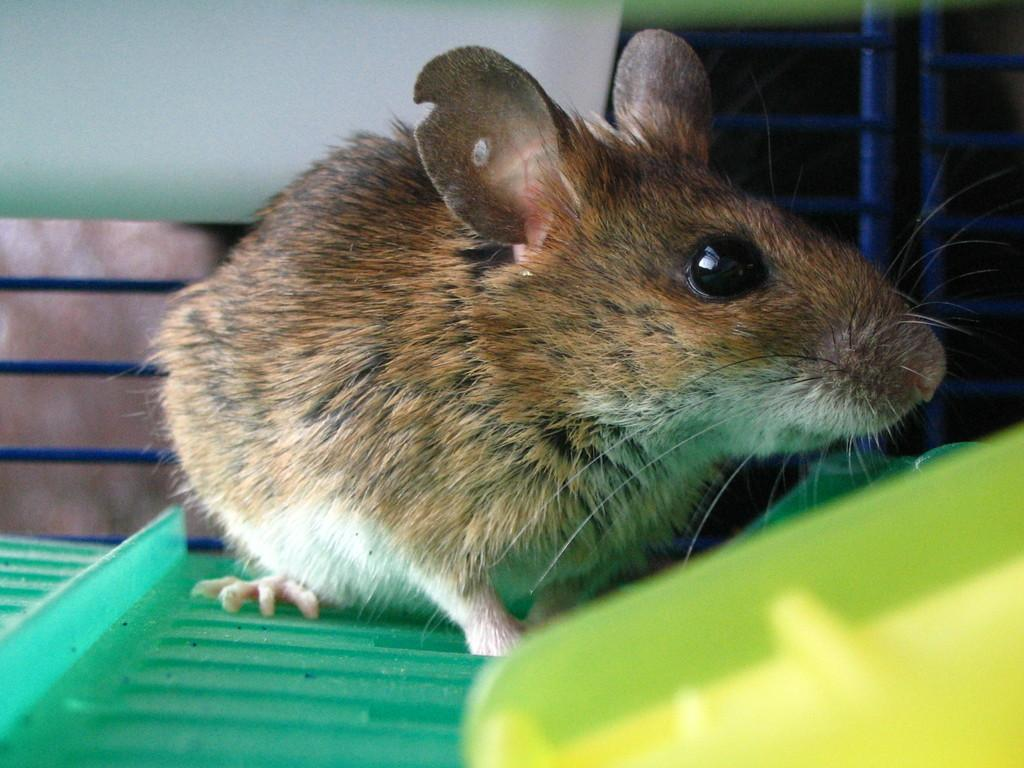What type of animal is present in the image? There is a rat in the image. What can be seen in the foreground of the image? There are objects in the foreground of the image. What type of material is used for some of the objects in the image? There are metal objects in the image. Can you describe the white colored object in the background of the image? There is a white colored object in the background of the image. What type of note is the person holding in the image? There is no person present in the image, and therefore no note can be observed. 